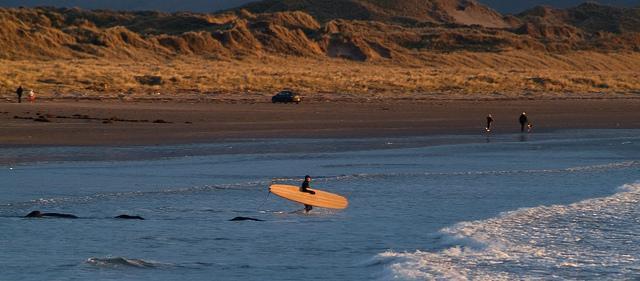How many sheep are there?
Give a very brief answer. 0. 